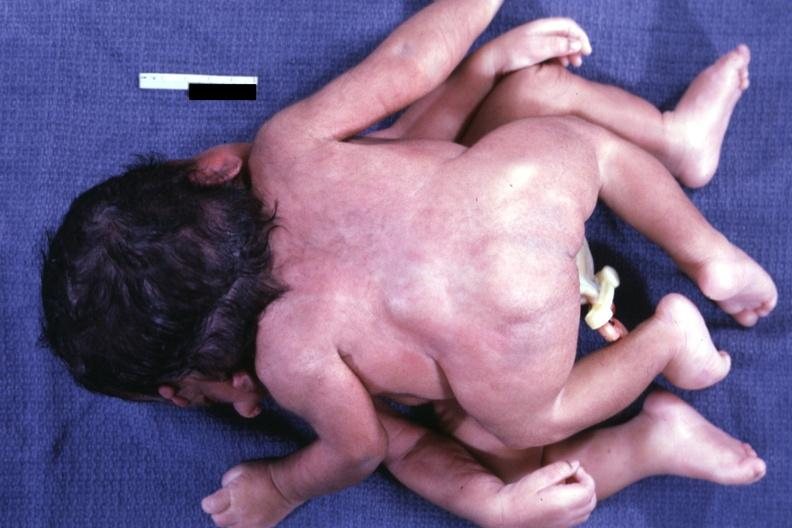does this image show posterior view?
Answer the question using a single word or phrase. Yes 